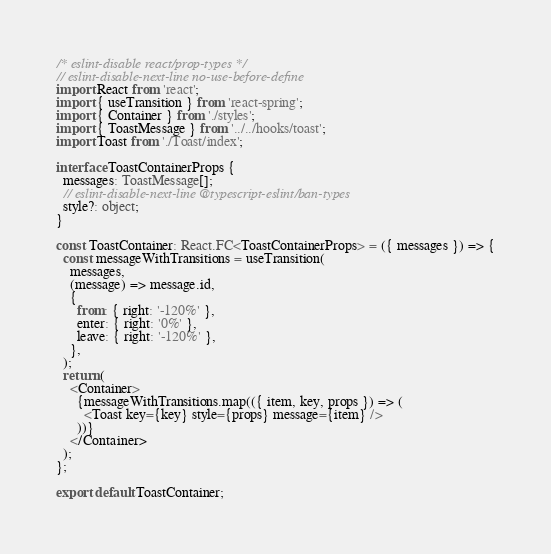Convert code to text. <code><loc_0><loc_0><loc_500><loc_500><_TypeScript_>/* eslint-disable react/prop-types */
// eslint-disable-next-line no-use-before-define
import React from 'react';
import { useTransition } from 'react-spring';
import { Container } from './styles';
import { ToastMessage } from '../../hooks/toast';
import Toast from './Toast/index';

interface ToastContainerProps {
  messages: ToastMessage[];
  // eslint-disable-next-line @typescript-eslint/ban-types
  style?: object;
}

const ToastContainer: React.FC<ToastContainerProps> = ({ messages }) => {
  const messageWithTransitions = useTransition(
    messages,
    (message) => message.id,
    {
      from: { right: '-120%' },
      enter: { right: '0%' },
      leave: { right: '-120%' },
    },
  );
  return (
    <Container>
      {messageWithTransitions.map(({ item, key, props }) => (
        <Toast key={key} style={props} message={item} />
      ))}
    </Container>
  );
};

export default ToastContainer;
</code> 